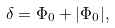Convert formula to latex. <formula><loc_0><loc_0><loc_500><loc_500>\delta = \Phi _ { 0 } + | \Phi _ { 0 } | ,</formula> 